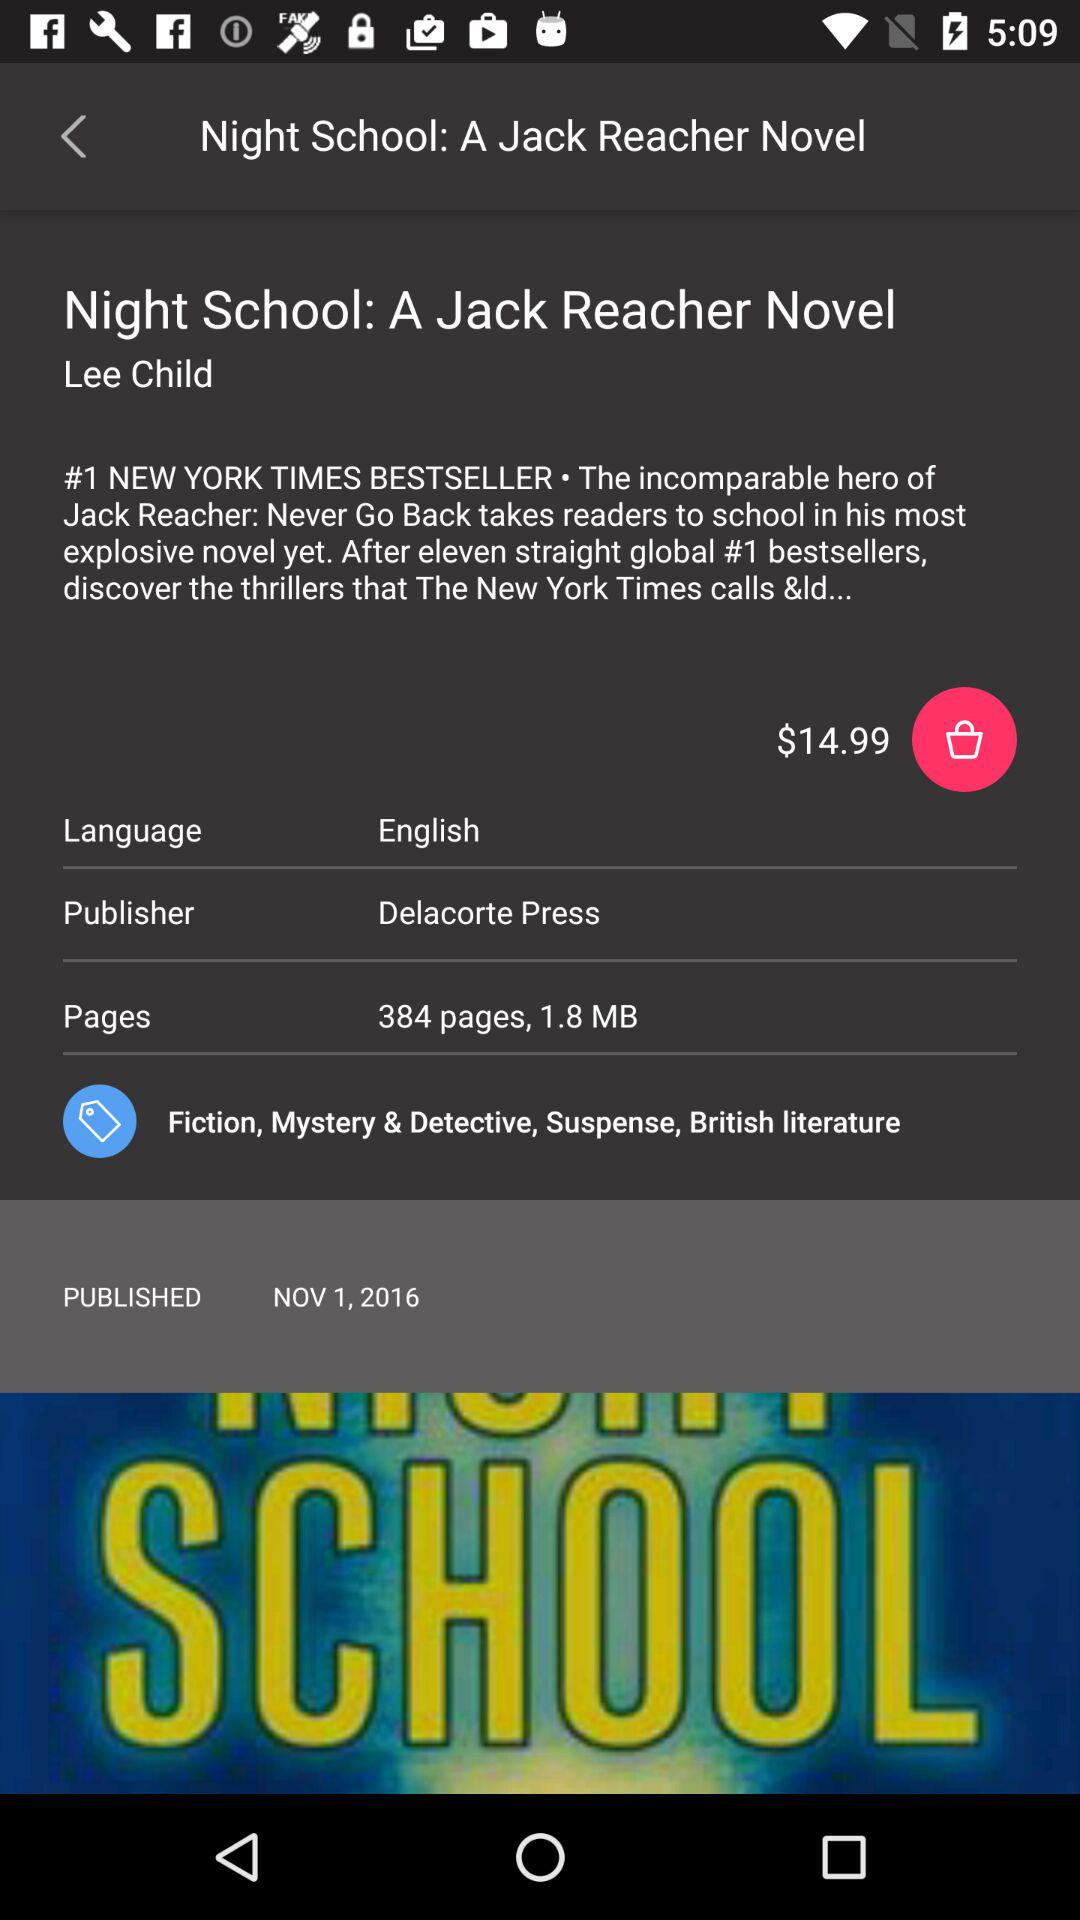How many pages does the book have?
Answer the question using a single word or phrase. 384 pages 